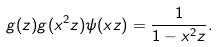<formula> <loc_0><loc_0><loc_500><loc_500>g ( z ) g ( x ^ { 2 } z ) \psi ( x z ) = \frac { 1 } { 1 - x ^ { 2 } z } .</formula> 